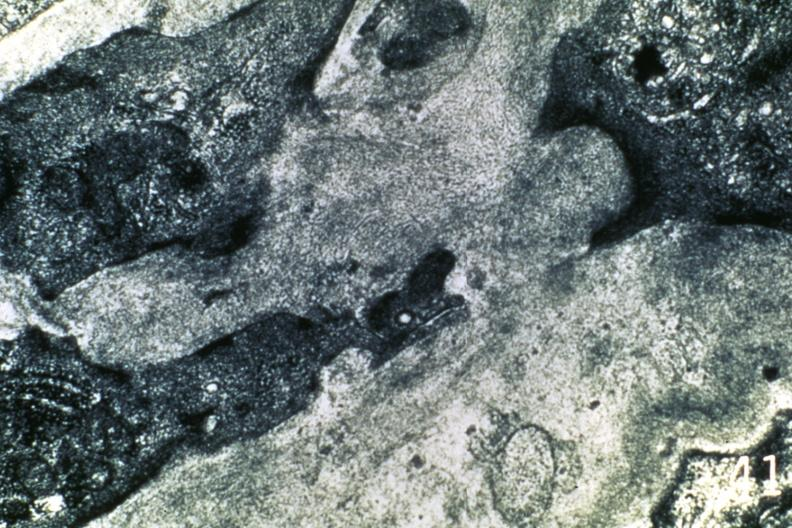s amyloidosis present?
Answer the question using a single word or phrase. Yes 